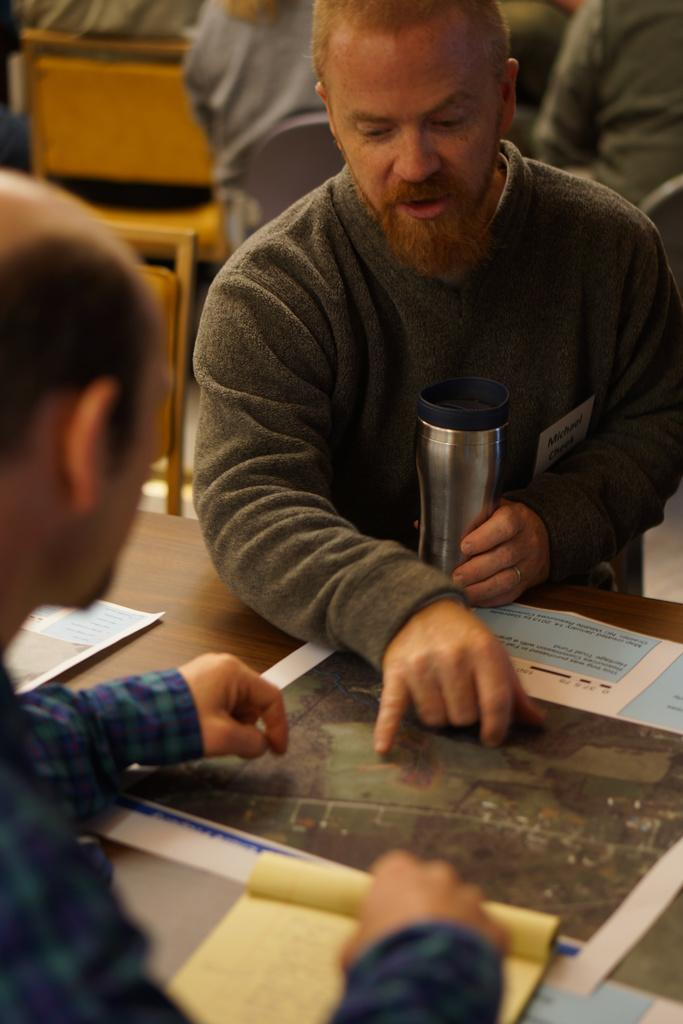What are the people in the image doing? There is a group of persons sitting on chairs in the image. What is one person holding? One person is holding a bottle in the image. What objects can be seen on the table in the foreground? In the foreground, there is a map, a paper, and a book on the table. What is the tendency of the rat in the image? There is no rat present in the image, so it is not possible to determine its tendency. 